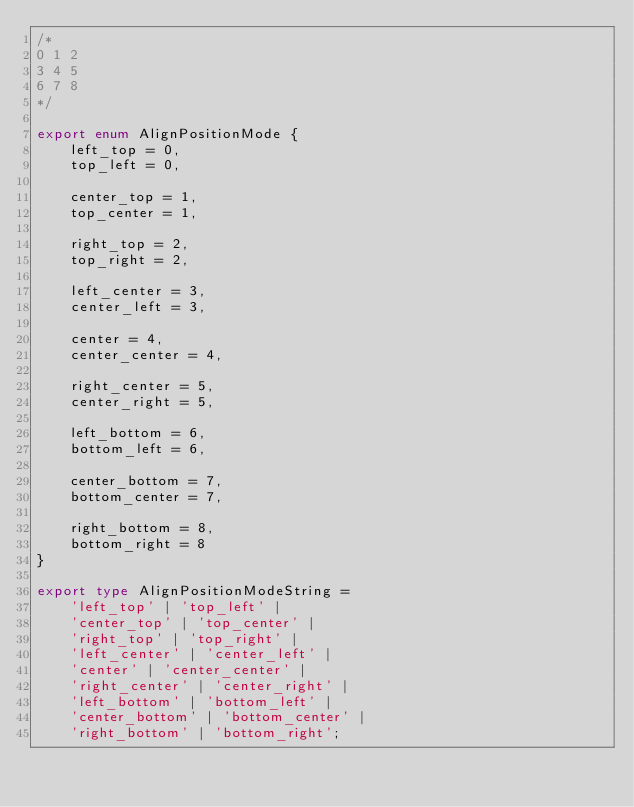<code> <loc_0><loc_0><loc_500><loc_500><_TypeScript_>/*
0 1 2
3 4 5
6 7 8
*/

export enum AlignPositionMode {
    left_top = 0,
    top_left = 0,

    center_top = 1,
    top_center = 1,

    right_top = 2,
    top_right = 2,

    left_center = 3,
    center_left = 3,

    center = 4,
    center_center = 4,

    right_center = 5,
    center_right = 5,

    left_bottom = 6,
    bottom_left = 6,

    center_bottom = 7,
    bottom_center = 7,

    right_bottom = 8,
    bottom_right = 8
}

export type AlignPositionModeString =
    'left_top' | 'top_left' |
    'center_top' | 'top_center' |
    'right_top' | 'top_right' |
    'left_center' | 'center_left' |
    'center' | 'center_center' |
    'right_center' | 'center_right' |
    'left_bottom' | 'bottom_left' |
    'center_bottom' | 'bottom_center' |
    'right_bottom' | 'bottom_right';</code> 